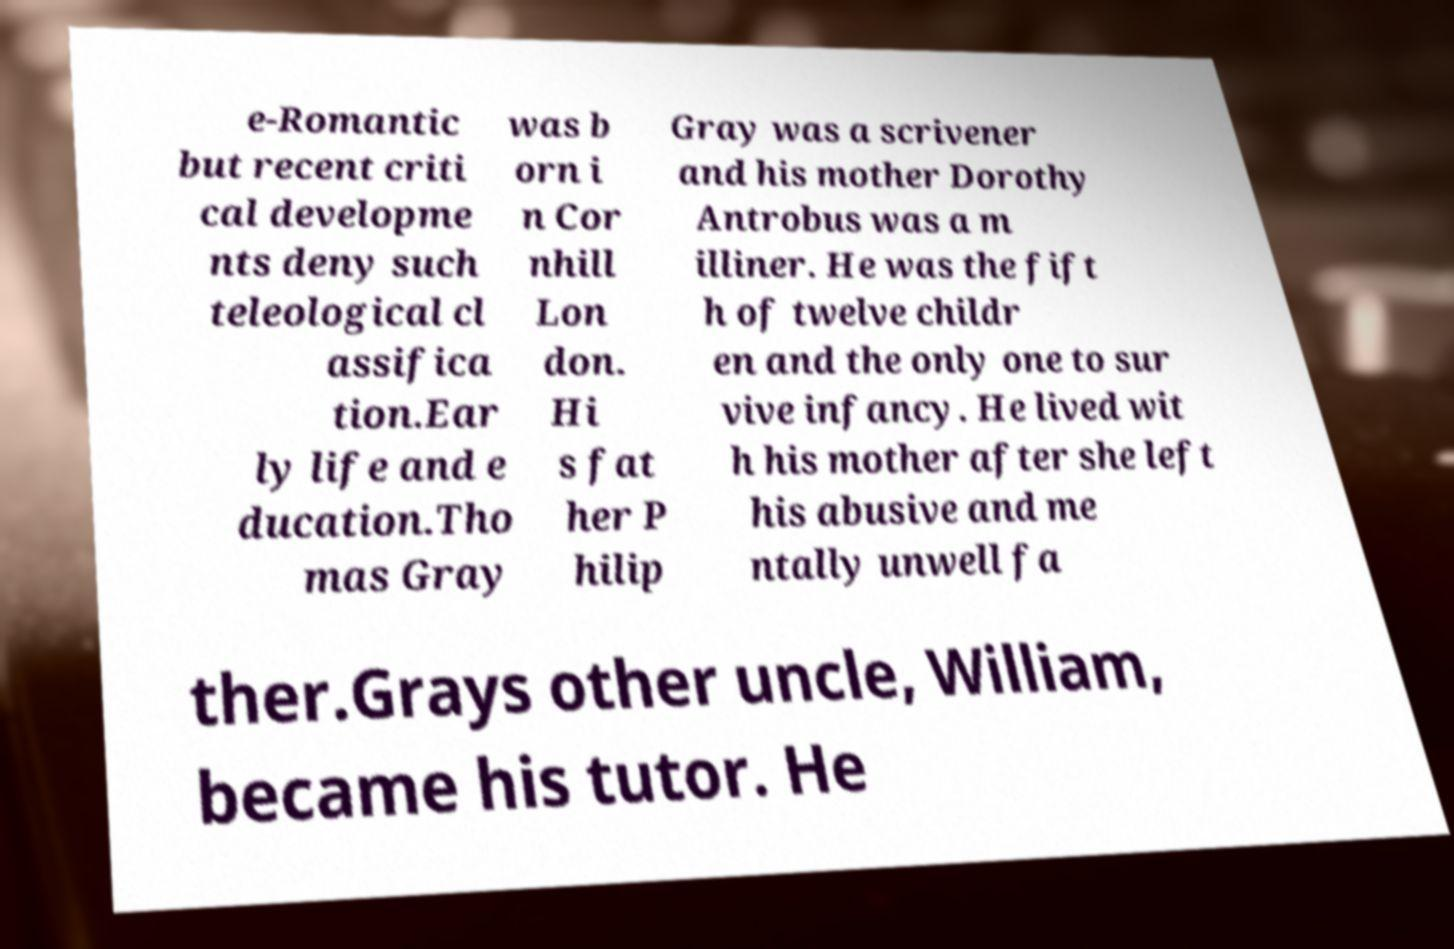Could you assist in decoding the text presented in this image and type it out clearly? e-Romantic but recent criti cal developme nts deny such teleological cl assifica tion.Ear ly life and e ducation.Tho mas Gray was b orn i n Cor nhill Lon don. Hi s fat her P hilip Gray was a scrivener and his mother Dorothy Antrobus was a m illiner. He was the fift h of twelve childr en and the only one to sur vive infancy. He lived wit h his mother after she left his abusive and me ntally unwell fa ther.Grays other uncle, William, became his tutor. He 